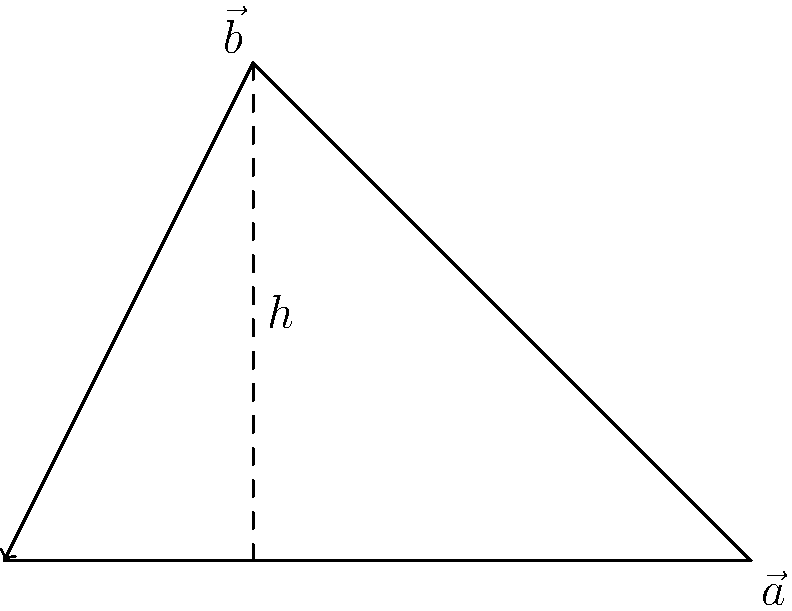In the CoDForums' latest vector challenge, you're presented with two vectors $\vec{a} = (3,0)$ and $\vec{b} = (1,2)$. What is the area of the parallelogram formed by these vectors? Express your answer in square units. Let's approach this step-by-step:

1) The area of a parallelogram can be calculated using the formula:
   $$ \text{Area} = |\vec{a} \times \vec{b}| $$
   where $\times$ denotes the cross product.

2) For 2D vectors $\vec{a} = (a_x, a_y)$ and $\vec{b} = (b_x, b_y)$, the cross product is defined as:
   $$ |\vec{a} \times \vec{b}| = |a_x b_y - a_y b_x| $$

3) Substituting our values:
   $\vec{a} = (3,0)$ and $\vec{b} = (1,2)$
   
   $$ |\vec{a} \times \vec{b}| = |(3)(2) - (0)(1)| $$

4) Calculating:
   $$ |\vec{a} \times \vec{b}| = |6 - 0| = 6 $$

5) Therefore, the area of the parallelogram is 6 square units.

Note: This method is equivalent to finding the base ($|\vec{a}| = 3$) and height ($h = 2$) of the parallelogram and using the formula $\text{Area} = \text{base} \times \text{height}$.
Answer: 6 square units 